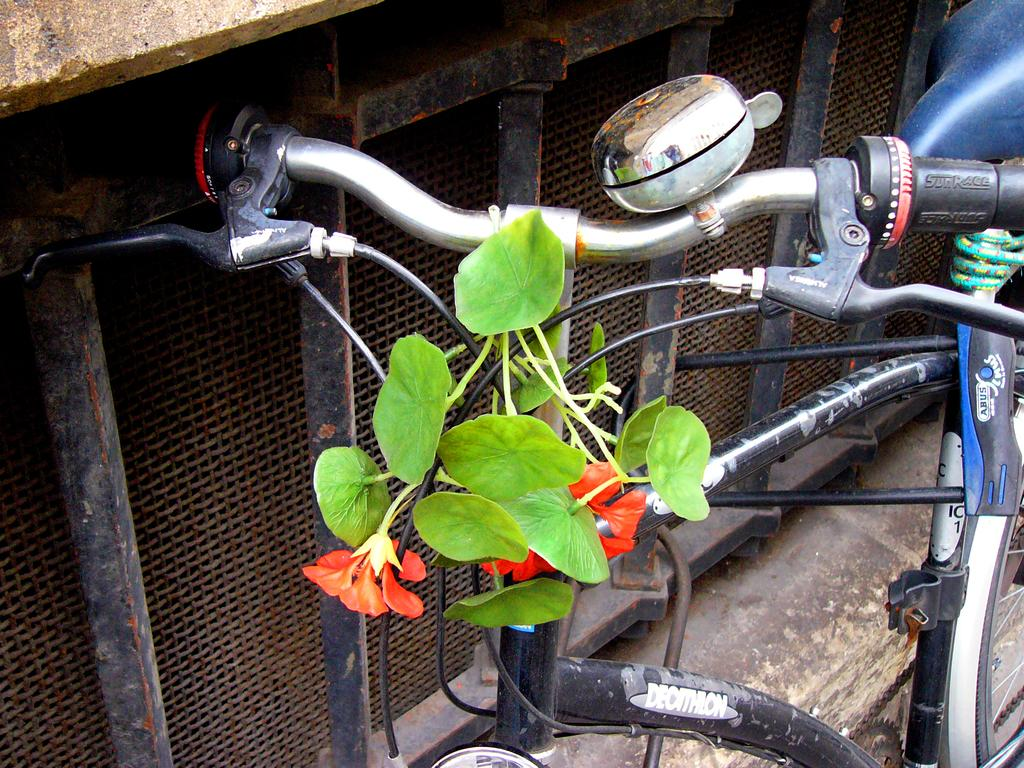What is the main subject of the picture? The main subject of the picture is a bicycle. What is unique about the bicycle's appearance? Leaves and flowers are present on the cables of the bicycle. Can you describe the background of the picture? There is an object in the background of the picture. How many sacks can be seen hanging from the handlebars of the bicycle? There are no sacks present on the bicycle in the image. What emotion is being expressed by the bicycle in the image? The bicycle is an inanimate object and cannot express emotions like hate. 